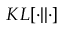Convert formula to latex. <formula><loc_0><loc_0><loc_500><loc_500>K L [ \cdot | | \cdot ]</formula> 